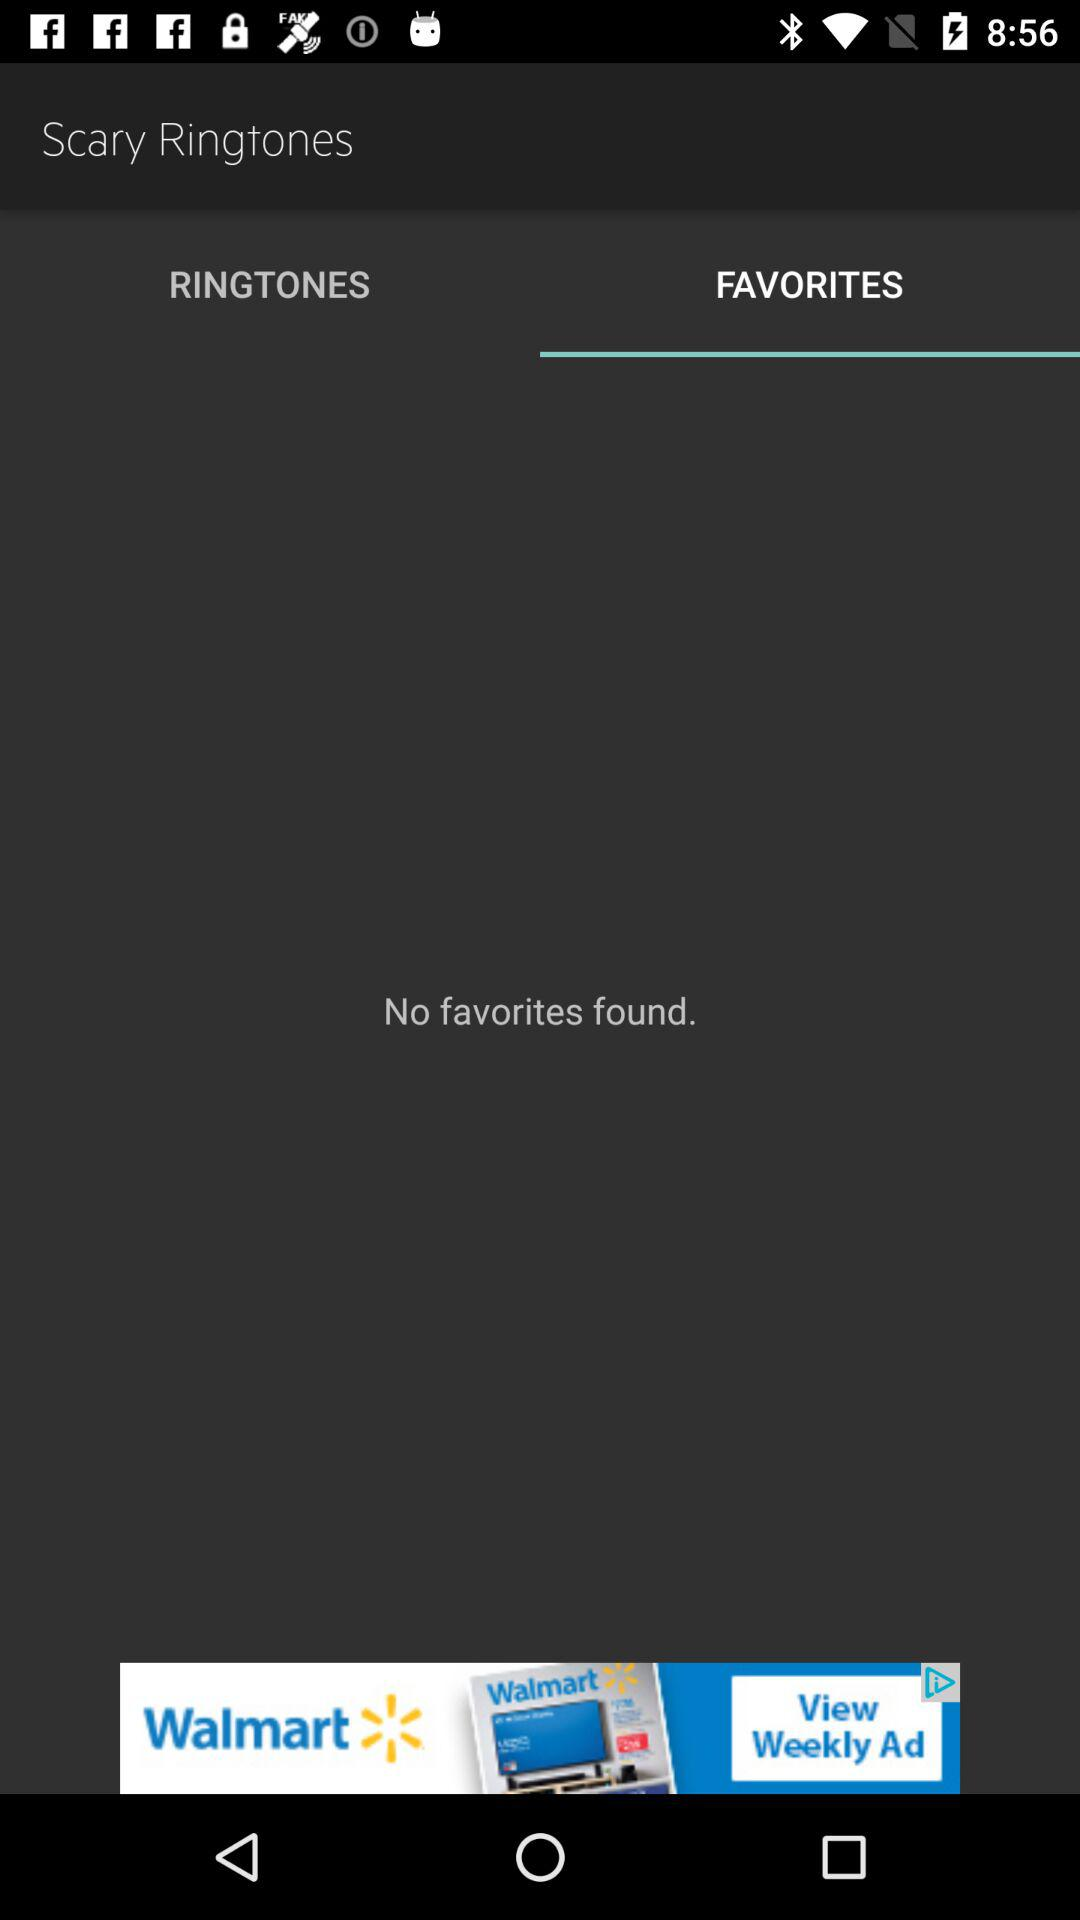Are there any favorites? There are no favorites. 